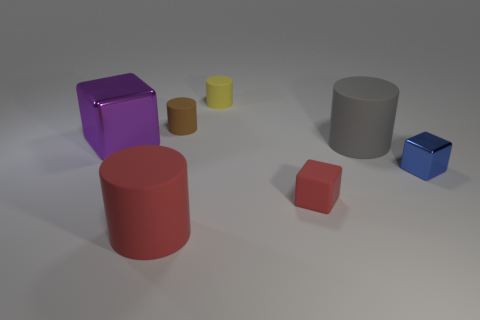There is a tiny brown cylinder that is to the left of the metal cube on the right side of the purple cube; what number of brown rubber things are behind it?
Offer a very short reply. 0. There is a brown matte object that is the same shape as the yellow rubber thing; what size is it?
Keep it short and to the point. Small. Is the small cylinder behind the small brown rubber cylinder made of the same material as the tiny brown cylinder?
Your response must be concise. Yes. What color is the rubber object that is the same shape as the big purple shiny object?
Provide a short and direct response. Red. How many other objects are there of the same color as the rubber block?
Offer a very short reply. 1. There is a red thing that is behind the big red rubber cylinder; does it have the same shape as the large thing right of the small brown cylinder?
Offer a terse response. No. How many spheres are large gray matte objects or small blue metal things?
Your answer should be compact. 0. Are there fewer metal objects left of the tiny yellow matte cylinder than brown rubber cylinders?
Offer a very short reply. No. What number of other objects are the same material as the blue object?
Provide a short and direct response. 1. Is the size of the red matte cylinder the same as the brown matte cylinder?
Offer a very short reply. No. 